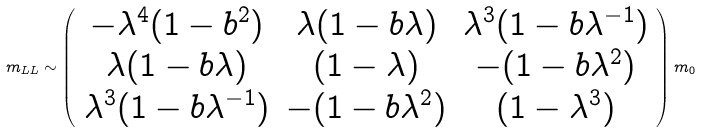<formula> <loc_0><loc_0><loc_500><loc_500>m _ { L L } \sim \left ( \begin{array} { c c c } - \lambda ^ { 4 } ( 1 - b ^ { 2 } ) & \lambda ( 1 - b \lambda ) & \lambda ^ { 3 } ( 1 - b \lambda ^ { - 1 } ) \\ \lambda ( 1 - b \lambda ) & ( 1 - \lambda ) & - ( 1 - b \lambda ^ { 2 } ) \\ \lambda ^ { 3 } ( 1 - b \lambda ^ { - 1 } ) & - ( 1 - b \lambda ^ { 2 } ) & ( 1 - \lambda ^ { 3 } ) \end{array} \right ) m _ { 0 }</formula> 